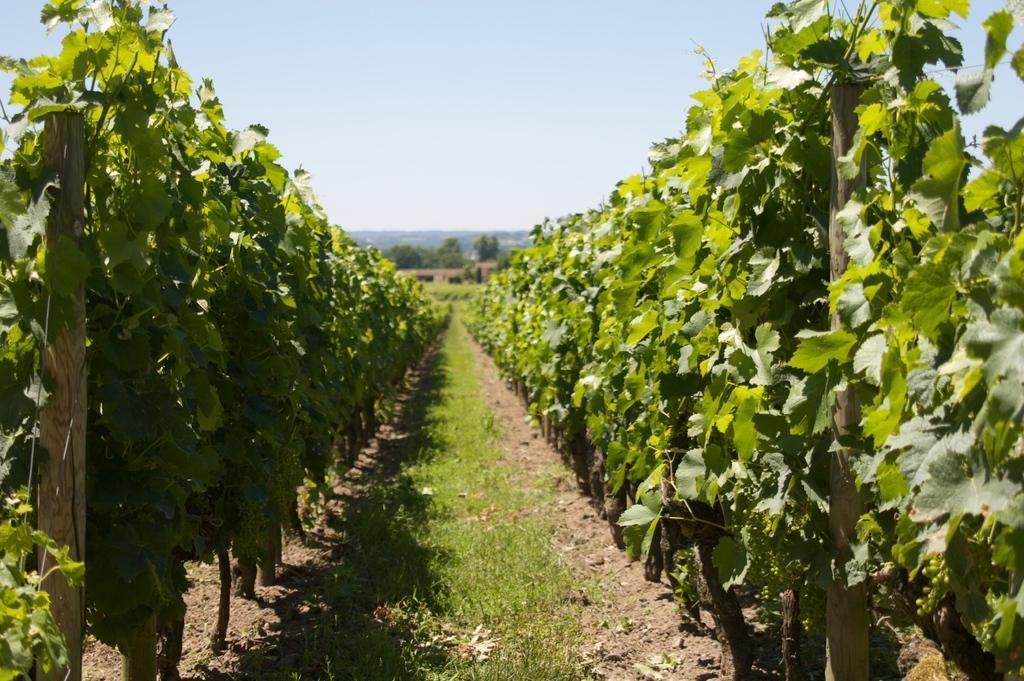What type of vegetation can be seen in the image? There are plants, grass, and trees in the image. What material are the sticks made of in the image? The sticks in the image are made of wood. What is visible in the background of the image? The sky is visible in the image. What type of meat can be seen hanging from the trees in the image? There is no meat present in the image; it features plants, grass, trees, and wooden sticks. 